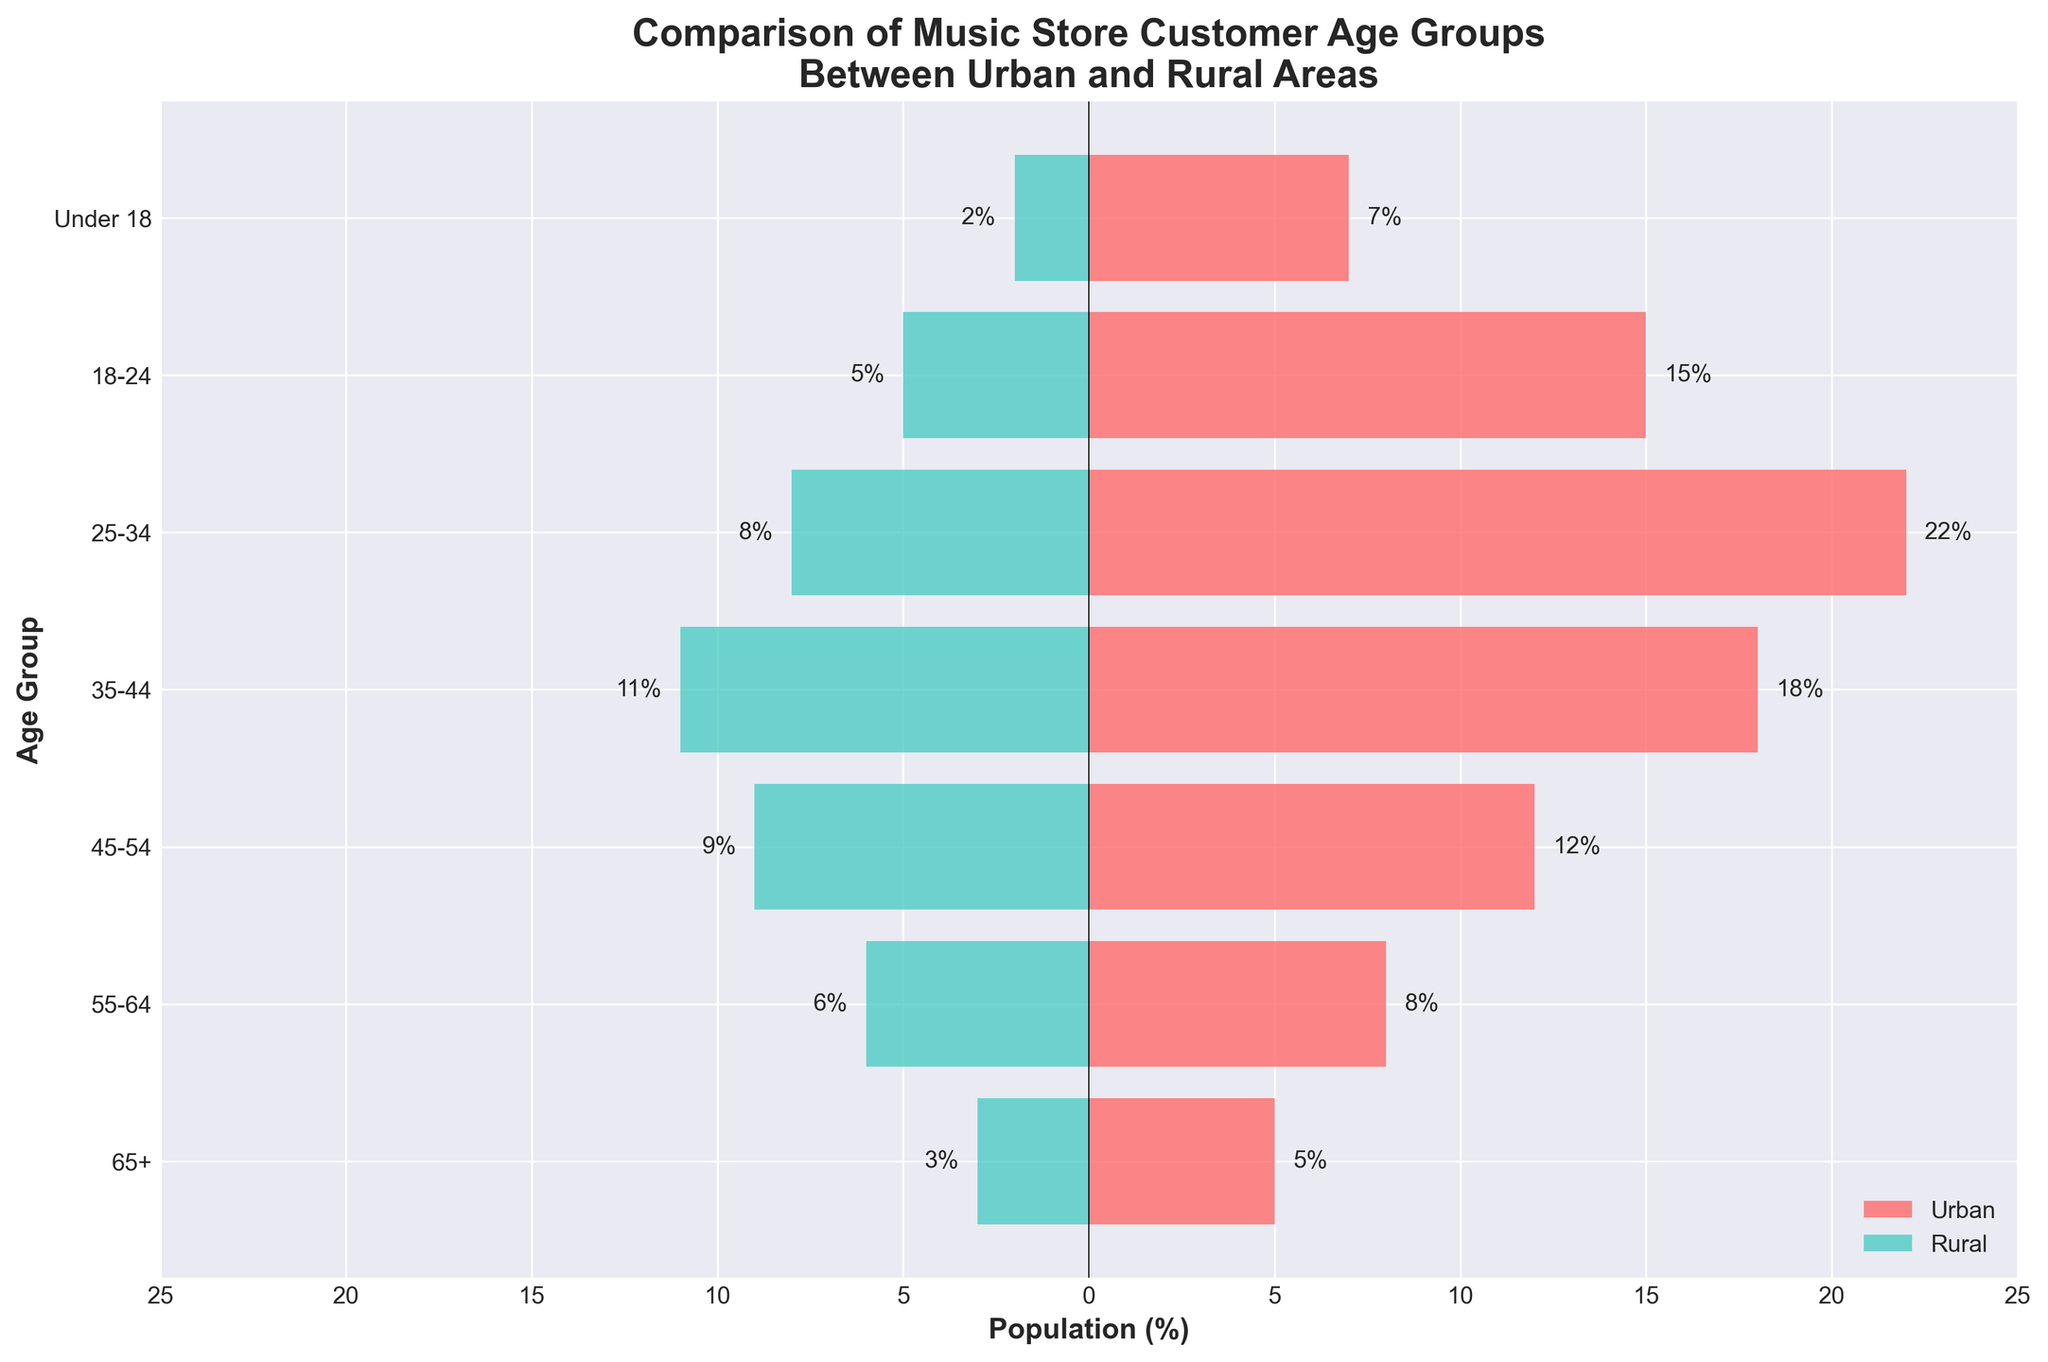How many age groups are compared in the figure? There are seven age groups listed on the y-axis of the figure, including '65+', '55-64', '45-54', '35-44', '25-34', '18-24', and 'Under 18'. These groups are used to compare urban and rural populations.
Answer: Seven Which age group has the highest percentage of customers in urban areas? The figure shows the bar lengths for each age group, with '25-34' having the longest bar for urban areas. This group is indicated to have the highest percentage of customers.
Answer: 25-34 What is the difference in the percentage of customers between urban and rural areas for the '35-44' age group? The '35-44' age group's bar for urban areas is 18%, and the bar for rural areas is 11%. The difference is calculated as 18% - 11%.
Answer: 7% Which age group has the smallest percentage of customers in rural areas? By observing the length of the bars representing rural areas, the 'Under 18' age group has the shortest bar at 2%, making it the smallest percentage.
Answer: Under 18 How does the customer percentage for the '55-64' age group compare between urban and rural areas? The '55-64' age group shows an urban percentage of 8%, while the rural percentage is 6% (absolute value of -6%). Comparing these two numbers, urban is higher than rural for this age group.
Answer: Urban is higher What is the sum of the percentages of urban customers from the '18-24' and '25-34' age groups? The percentage of urban customers for '18-24' is 15% and for '25-34' is 22%. Summing these values: 15% + 22% = 37%.
Answer: 37% Which age group shows the greatest disparity between urban and rural areas? By comparing the lengths of bars representing each age group, the '35-44' group shows a disparity of 18% (urban) and 11% (rural), resulting in a maximum difference of 7%. This is the greatest among all groups.
Answer: 35-44 In rural areas, which age group has a higher customer percentage, the '65+' or '45-54' group? The rural percentage for the '65+' group is 3%, while for '45-54' it is 9%. 9% is greater than 3%, indicating the '45-54' group is higher in rural areas.
Answer: 45-54 What is the total percentage of customers under 35 in urban areas? Adding up the percentages for 'Under 18', '18-24', and '25-34': 7% + 15% + 22% = 44%.
Answer: 44% 